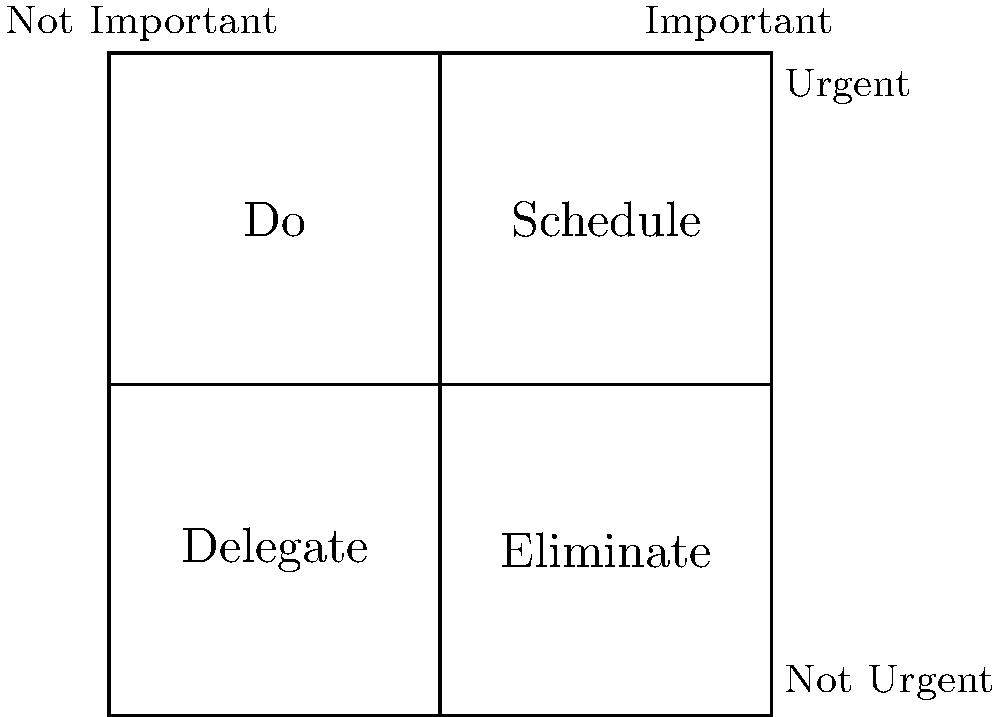As a corporate employee who values structure, you're tasked with prioritizing your workload using the Eisenhower Matrix shown above. Which quadrant should you focus on first to maximize productivity and align with your preference for a structured environment? To answer this question, let's analyze the Eisenhower Matrix and its quadrants:

1. The matrix is divided into four quadrants based on urgency and importance.
2. The top-left quadrant (Do) represents tasks that are both urgent and important.
3. The top-right quadrant (Schedule) represents tasks that are important but not urgent.
4. The bottom-left quadrant (Delegate) represents tasks that are urgent but not important.
5. The bottom-right quadrant (Eliminate) represents tasks that are neither urgent nor important.

Given your persona as a corporate employee who prefers a structured environment:

1. The "Do" quadrant (urgent and important) should be your primary focus. These tasks require immediate attention and align with your structured approach.
2. Addressing these tasks first helps maintain order and prevents last-minute rushes, which can disrupt your preferred structured workflow.
3. By tackling urgent and important tasks promptly, you create a more controlled work environment, reducing stress and increasing productivity.
4. This approach also allows you to allocate time for the "Schedule" quadrant later, which is crucial for long-term planning and maintaining structure in your work.

Therefore, to maximize productivity and align with your preference for a structured environment, you should focus on the "Do" quadrant (urgent and important tasks) first.
Answer: Do quadrant (urgent and important) 